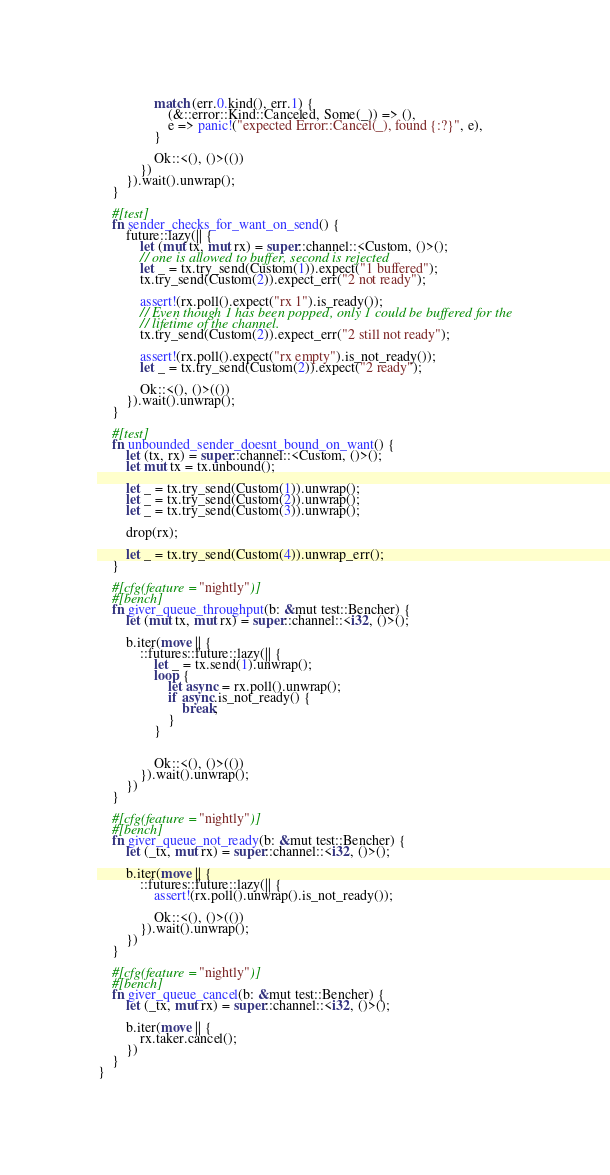Convert code to text. <code><loc_0><loc_0><loc_500><loc_500><_Rust_>
                match (err.0.kind(), err.1) {
                    (&::error::Kind::Canceled, Some(_)) => (),
                    e => panic!("expected Error::Cancel(_), found {:?}", e),
                }

                Ok::<(), ()>(())
            })
        }).wait().unwrap();
    }

    #[test]
    fn sender_checks_for_want_on_send() {
        future::lazy(|| {
            let (mut tx, mut rx) = super::channel::<Custom, ()>();
            // one is allowed to buffer, second is rejected
            let _ = tx.try_send(Custom(1)).expect("1 buffered");
            tx.try_send(Custom(2)).expect_err("2 not ready");

            assert!(rx.poll().expect("rx 1").is_ready());
            // Even though 1 has been popped, only 1 could be buffered for the
            // lifetime of the channel.
            tx.try_send(Custom(2)).expect_err("2 still not ready");

            assert!(rx.poll().expect("rx empty").is_not_ready());
            let _ = tx.try_send(Custom(2)).expect("2 ready");

            Ok::<(), ()>(())
        }).wait().unwrap();
    }

    #[test]
    fn unbounded_sender_doesnt_bound_on_want() {
        let (tx, rx) = super::channel::<Custom, ()>();
        let mut tx = tx.unbound();

        let _ = tx.try_send(Custom(1)).unwrap();
        let _ = tx.try_send(Custom(2)).unwrap();
        let _ = tx.try_send(Custom(3)).unwrap();

        drop(rx);

        let _ = tx.try_send(Custom(4)).unwrap_err();
    }

    #[cfg(feature = "nightly")]
    #[bench]
    fn giver_queue_throughput(b: &mut test::Bencher) {
        let (mut tx, mut rx) = super::channel::<i32, ()>();

        b.iter(move || {
            ::futures::future::lazy(|| {
                let _ = tx.send(1).unwrap();
                loop {
                    let async = rx.poll().unwrap();
                    if async.is_not_ready() {
                        break;
                    }
                }


                Ok::<(), ()>(())
            }).wait().unwrap();
        })
    }

    #[cfg(feature = "nightly")]
    #[bench]
    fn giver_queue_not_ready(b: &mut test::Bencher) {
        let (_tx, mut rx) = super::channel::<i32, ()>();

        b.iter(move || {
            ::futures::future::lazy(|| {
                assert!(rx.poll().unwrap().is_not_ready());

                Ok::<(), ()>(())
            }).wait().unwrap();
        })
    }

    #[cfg(feature = "nightly")]
    #[bench]
    fn giver_queue_cancel(b: &mut test::Bencher) {
        let (_tx, mut rx) = super::channel::<i32, ()>();

        b.iter(move || {
            rx.taker.cancel();
        })
    }
}
</code> 